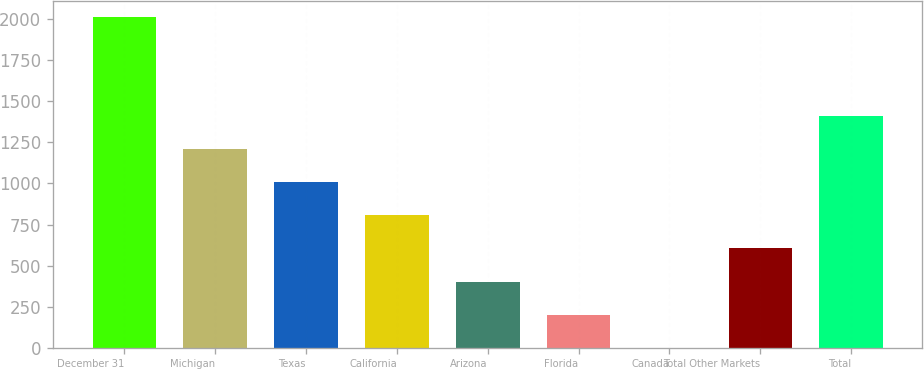Convert chart. <chart><loc_0><loc_0><loc_500><loc_500><bar_chart><fcel>December 31<fcel>Michigan<fcel>Texas<fcel>California<fcel>Arizona<fcel>Florida<fcel>Canada<fcel>Total Other Markets<fcel>Total<nl><fcel>2012<fcel>1207.6<fcel>1006.5<fcel>805.4<fcel>403.2<fcel>202.1<fcel>1<fcel>604.3<fcel>1408.7<nl></chart> 